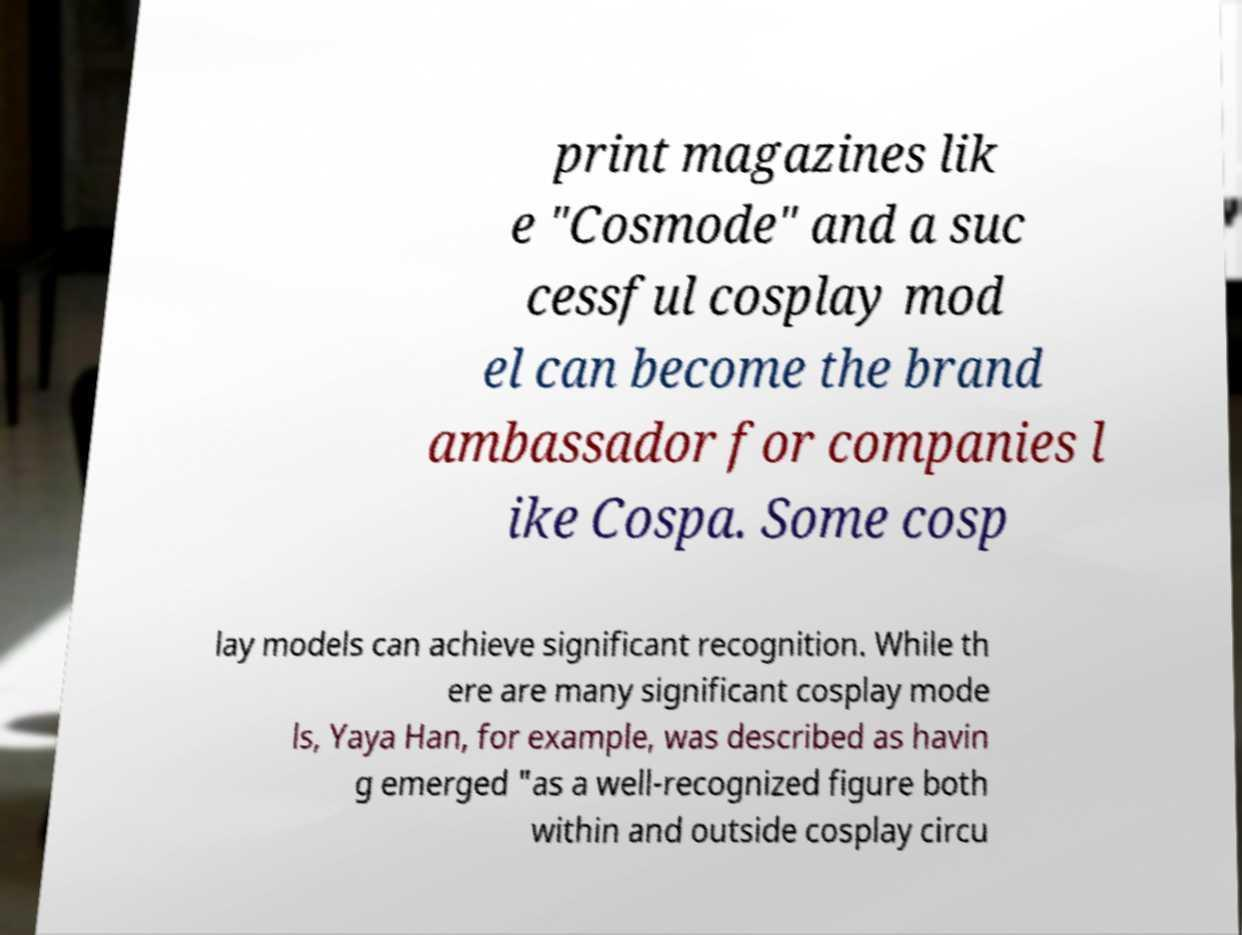There's text embedded in this image that I need extracted. Can you transcribe it verbatim? print magazines lik e "Cosmode" and a suc cessful cosplay mod el can become the brand ambassador for companies l ike Cospa. Some cosp lay models can achieve significant recognition. While th ere are many significant cosplay mode ls, Yaya Han, for example, was described as havin g emerged "as a well-recognized figure both within and outside cosplay circu 